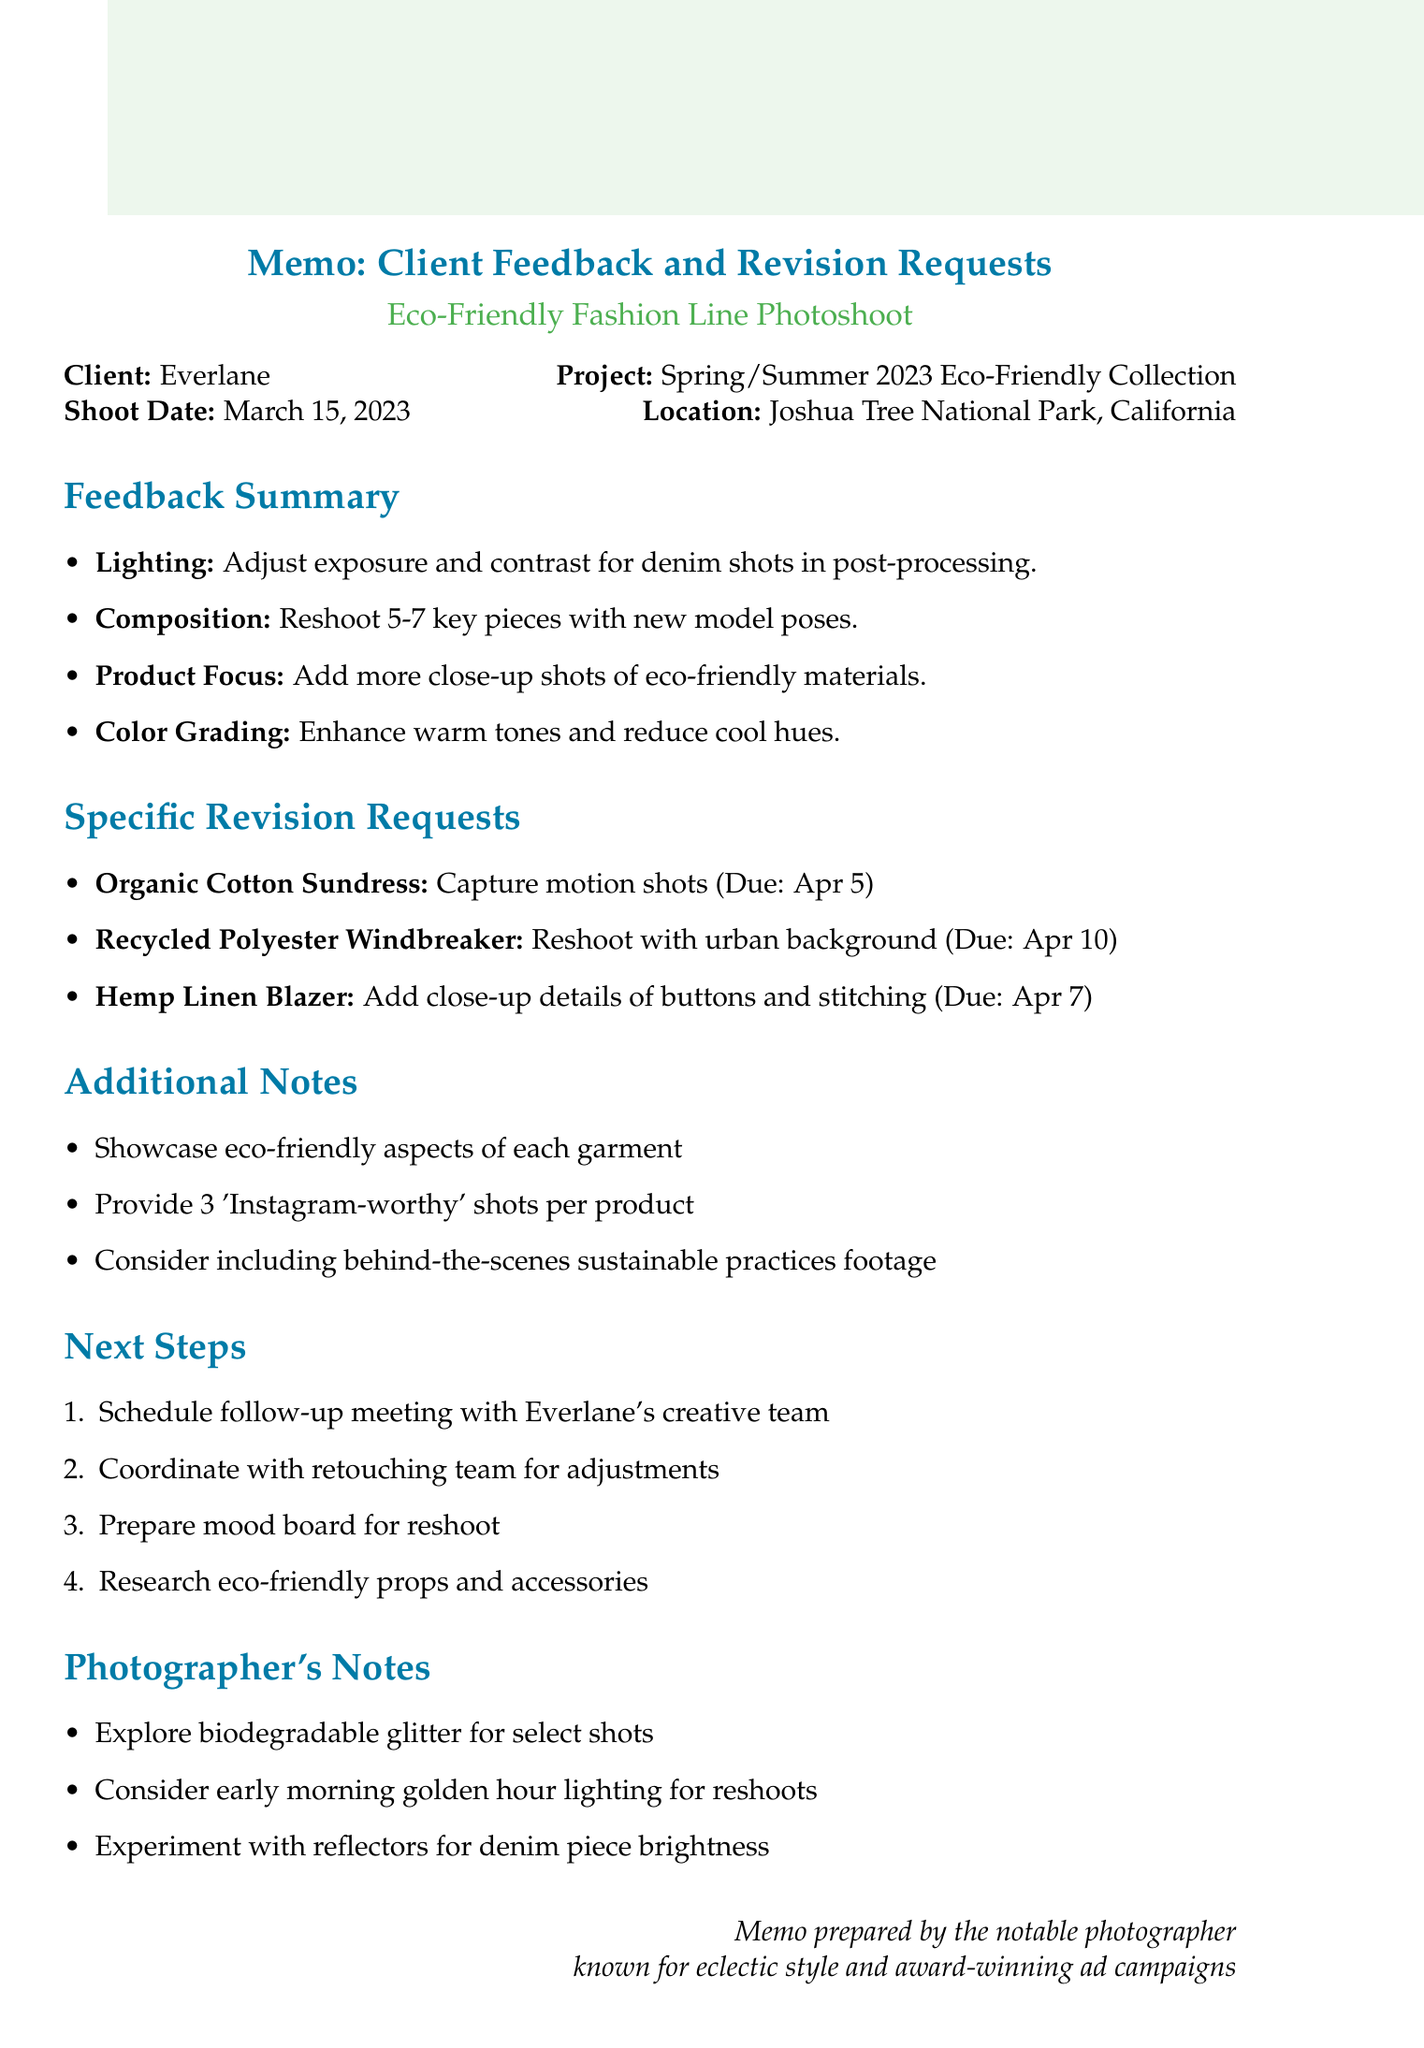What is the client's name? The client's name is explicitly mentioned in the document.
Answer: Everlane When was the photoshoot conducted? The date of the shoot is stated in the document.
Answer: March 15, 2023 What location was used for the photoshoot? The location is specified directly in the memo.
Answer: Joshua Tree National Park, California How many specific revision requests are listed? The number of revision requests can be counted from the section in the document.
Answer: 3 What aspect of the photoshoot did the client praise? The aspect praised is outlined in the feedback summary.
Answer: Natural lighting What deadline is set for the Organic Cotton Sundress shots? The deadline for the requested shots is mentioned directly.
Answer: April 5 What action item was requested for the denim shots? The action item is outlined in the feedback section of the memo.
Answer: Adjust exposure and contrast in post-processing What type of shots did the social media team request? The requested type of shots is detailed in the additional notes section.
Answer: 'Instagram-worthy' shots What should be researched for the next steps? The next step includes a specific area of research outlined in the memo.
Answer: Eco-friendly props and accessories 